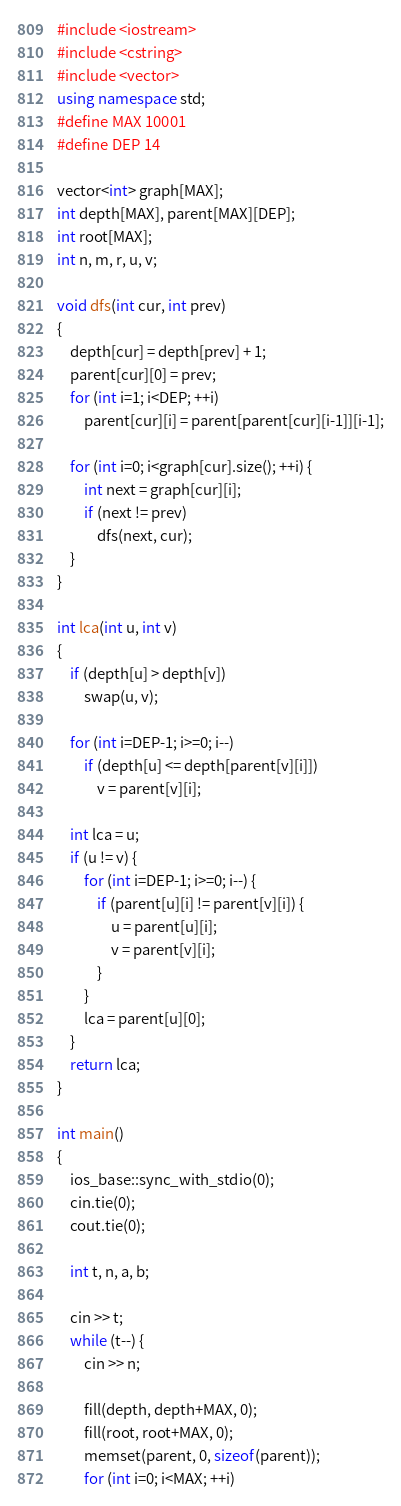Convert code to text. <code><loc_0><loc_0><loc_500><loc_500><_C++_>#include <iostream>
#include <cstring>
#include <vector>
using namespace std;
#define MAX 10001
#define DEP 14

vector<int> graph[MAX];
int depth[MAX], parent[MAX][DEP];
int root[MAX];
int n, m, r, u, v;

void dfs(int cur, int prev)
{
	depth[cur] = depth[prev] + 1;
	parent[cur][0] = prev;
	for (int i=1; i<DEP; ++i)
		parent[cur][i] = parent[parent[cur][i-1]][i-1];

	for (int i=0; i<graph[cur].size(); ++i) {
		int next = graph[cur][i];
		if (next != prev)
			dfs(next, cur);
	}
}

int lca(int u, int v)
{
	if (depth[u] > depth[v])
		swap(u, v);

	for (int i=DEP-1; i>=0; i--)
		if (depth[u] <= depth[parent[v][i]])
			v = parent[v][i];

	int lca = u;
	if (u != v) {
		for (int i=DEP-1; i>=0; i--) {
			if (parent[u][i] != parent[v][i]) {
				u = parent[u][i];
				v = parent[v][i];
			}
		}
		lca = parent[u][0];
	}
	return lca;
}

int main()
{
	ios_base::sync_with_stdio(0);
	cin.tie(0);
	cout.tie(0);

	int t, n, a, b;

	cin >> t;
	while (t--) {
		cin >> n;

		fill(depth, depth+MAX, 0);
		fill(root, root+MAX, 0);
		memset(parent, 0, sizeof(parent));
		for (int i=0; i<MAX; ++i)</code> 